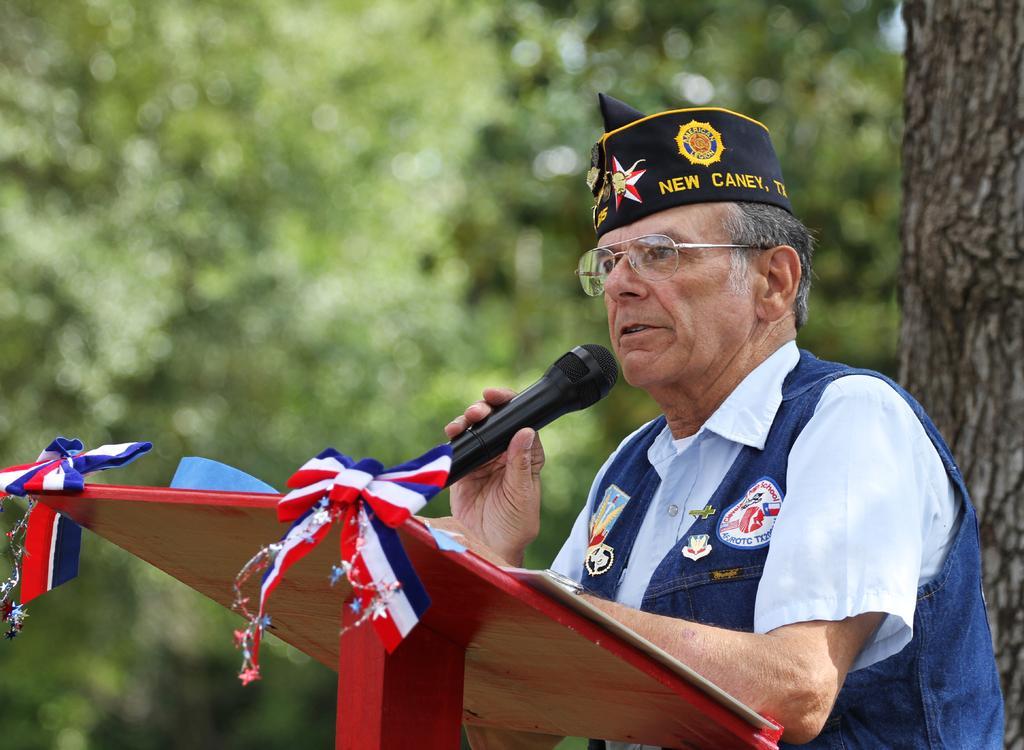In one or two sentences, can you explain what this image depicts? In this image there is an officer who is standing in front of the podium by holding the mic. He is having a cap. On the right side there is a tree. In the background there are trees with green leaves. 